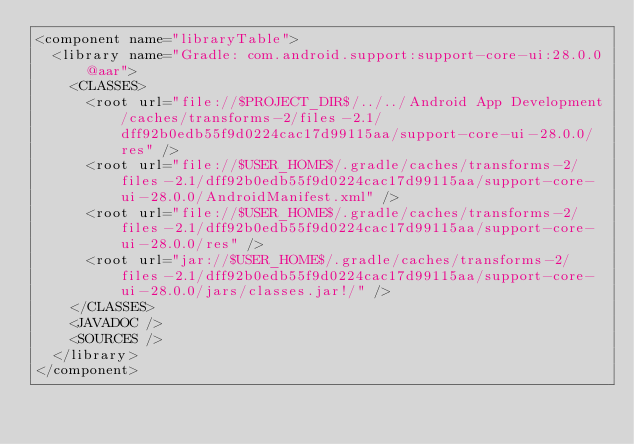<code> <loc_0><loc_0><loc_500><loc_500><_XML_><component name="libraryTable">
  <library name="Gradle: com.android.support:support-core-ui:28.0.0@aar">
    <CLASSES>
      <root url="file://$PROJECT_DIR$/../../Android App Development/caches/transforms-2/files-2.1/dff92b0edb55f9d0224cac17d99115aa/support-core-ui-28.0.0/res" />
      <root url="file://$USER_HOME$/.gradle/caches/transforms-2/files-2.1/dff92b0edb55f9d0224cac17d99115aa/support-core-ui-28.0.0/AndroidManifest.xml" />
      <root url="file://$USER_HOME$/.gradle/caches/transforms-2/files-2.1/dff92b0edb55f9d0224cac17d99115aa/support-core-ui-28.0.0/res" />
      <root url="jar://$USER_HOME$/.gradle/caches/transforms-2/files-2.1/dff92b0edb55f9d0224cac17d99115aa/support-core-ui-28.0.0/jars/classes.jar!/" />
    </CLASSES>
    <JAVADOC />
    <SOURCES />
  </library>
</component></code> 